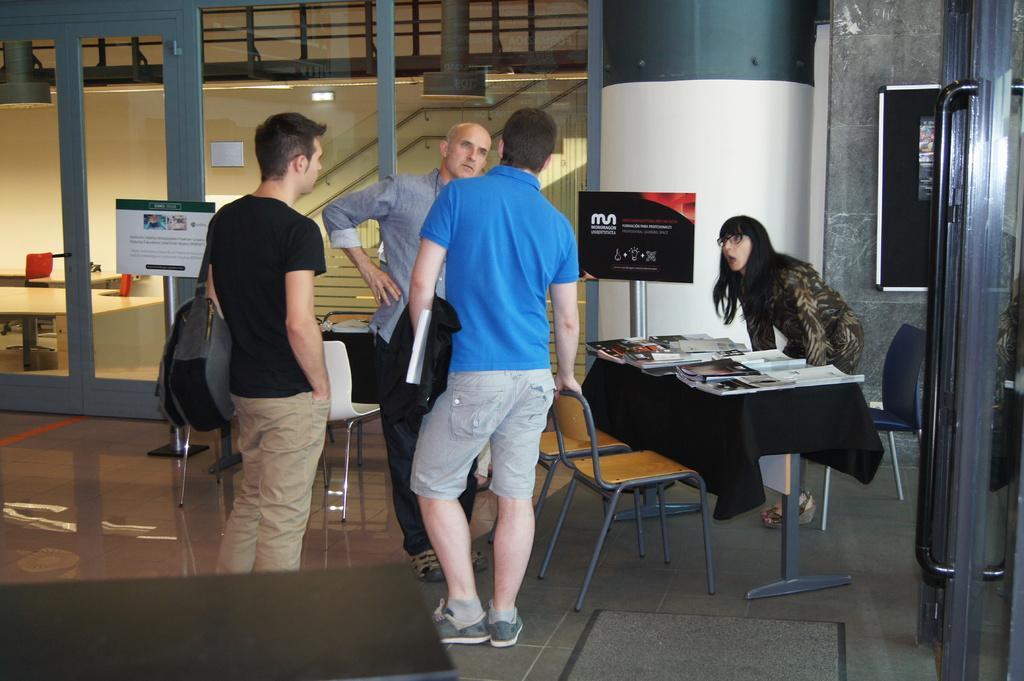Can you describe this image briefly? In this picture we can see three men and one woman standing and this two are looking at each other and in front of them on table we have books, papers and in background we can see glass, banner, board. 